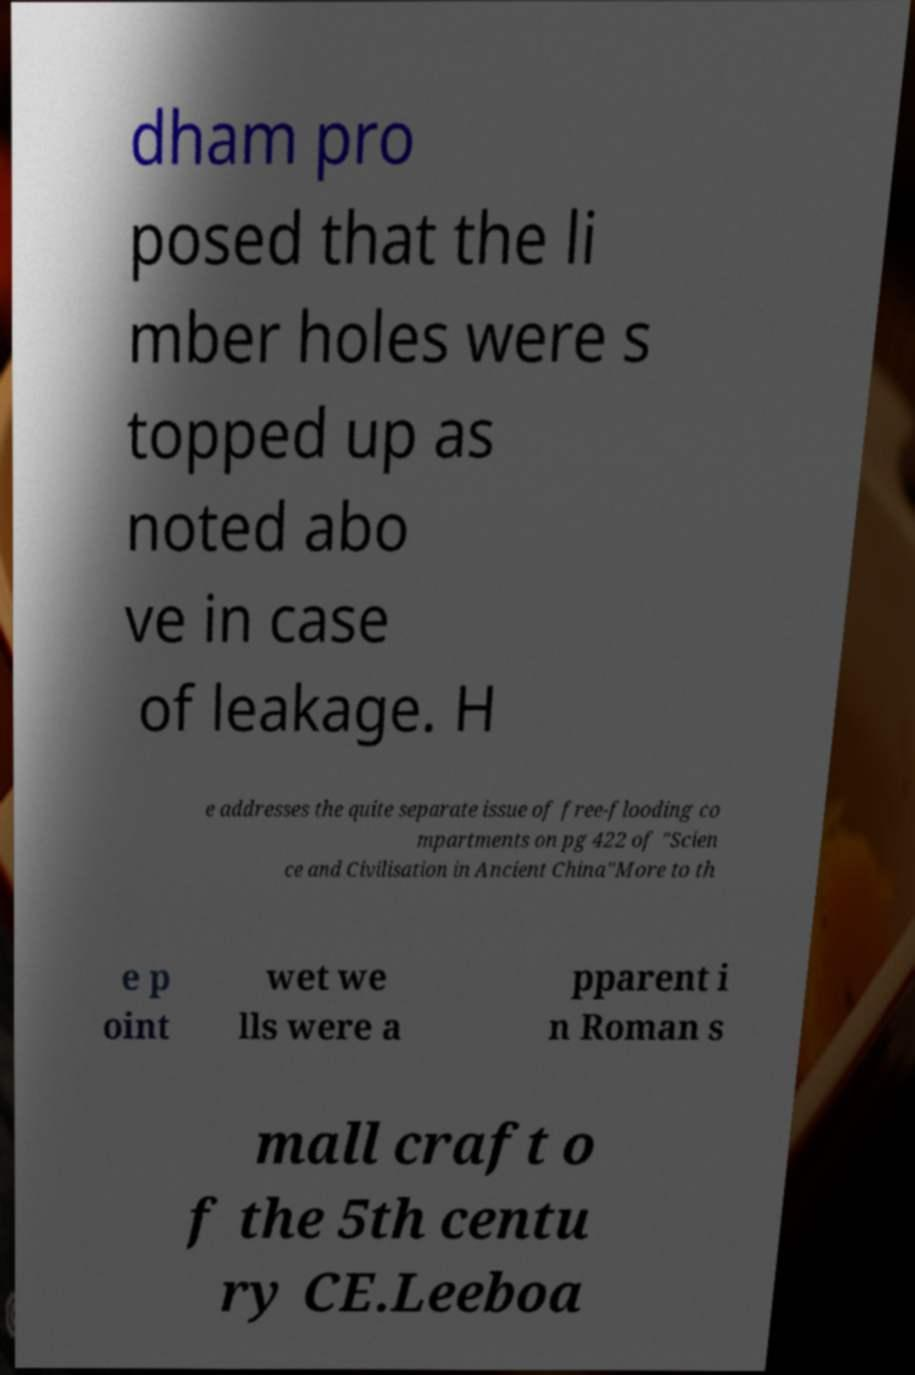Please read and relay the text visible in this image. What does it say? dham pro posed that the li mber holes were s topped up as noted abo ve in case of leakage. H e addresses the quite separate issue of free-flooding co mpartments on pg 422 of "Scien ce and Civilisation in Ancient China"More to th e p oint wet we lls were a pparent i n Roman s mall craft o f the 5th centu ry CE.Leeboa 